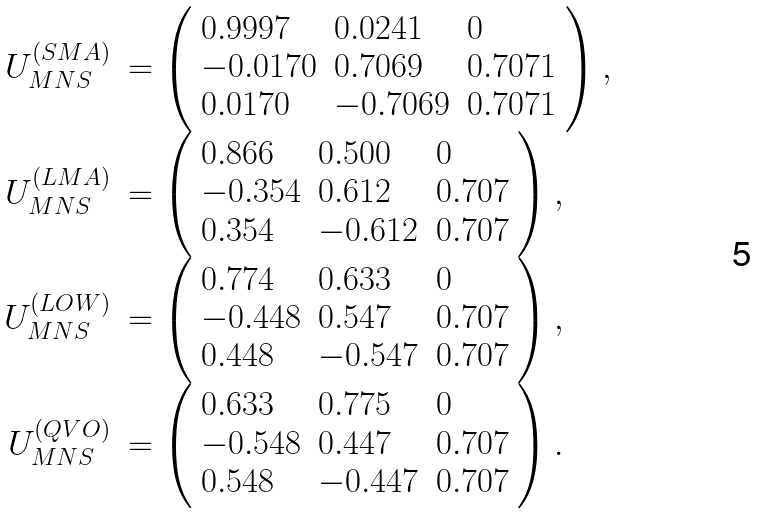<formula> <loc_0><loc_0><loc_500><loc_500>\begin{array} { r l } { { U _ { M N S } ^ { ( S M A ) } } } & { { = \left ( \begin{array} { l l l } { 0 . 9 9 9 7 } & { 0 . 0 2 4 1 } & { 0 } \\ { - 0 . 0 1 7 0 } & { 0 . 7 0 6 9 } & { 0 . 7 0 7 1 } \\ { 0 . 0 1 7 0 } & { - 0 . 7 0 6 9 } & { 0 . 7 0 7 1 } \end{array} \right ) , } } \\ { { U _ { M N S } ^ { ( L M A ) } } } & { { = \left ( \begin{array} { l l l } { 0 . 8 6 6 } & { 0 . 5 0 0 } & { 0 } \\ { - 0 . 3 5 4 } & { 0 . 6 1 2 } & { 0 . 7 0 7 } \\ { 0 . 3 5 4 } & { - 0 . 6 1 2 } & { 0 . 7 0 7 } \end{array} \right ) , } } \\ { { U _ { M N S } ^ { ( L O W ) } } } & { { = \left ( \begin{array} { l l l } { 0 . 7 7 4 } & { 0 . 6 3 3 } & { 0 } \\ { - 0 . 4 4 8 } & { 0 . 5 4 7 } & { 0 . 7 0 7 } \\ { 0 . 4 4 8 } & { - 0 . 5 4 7 } & { 0 . 7 0 7 } \end{array} \right ) , } } \\ { { U _ { M N S } ^ { ( Q V O ) } } } & { { = \left ( \begin{array} { l l l } { 0 . 6 3 3 } & { 0 . 7 7 5 } & { 0 } \\ { - 0 . 5 4 8 } & { 0 . 4 4 7 } & { 0 . 7 0 7 } \\ { 0 . 5 4 8 } & { - 0 . 4 4 7 } & { 0 . 7 0 7 } \end{array} \right ) . } } \end{array}</formula> 